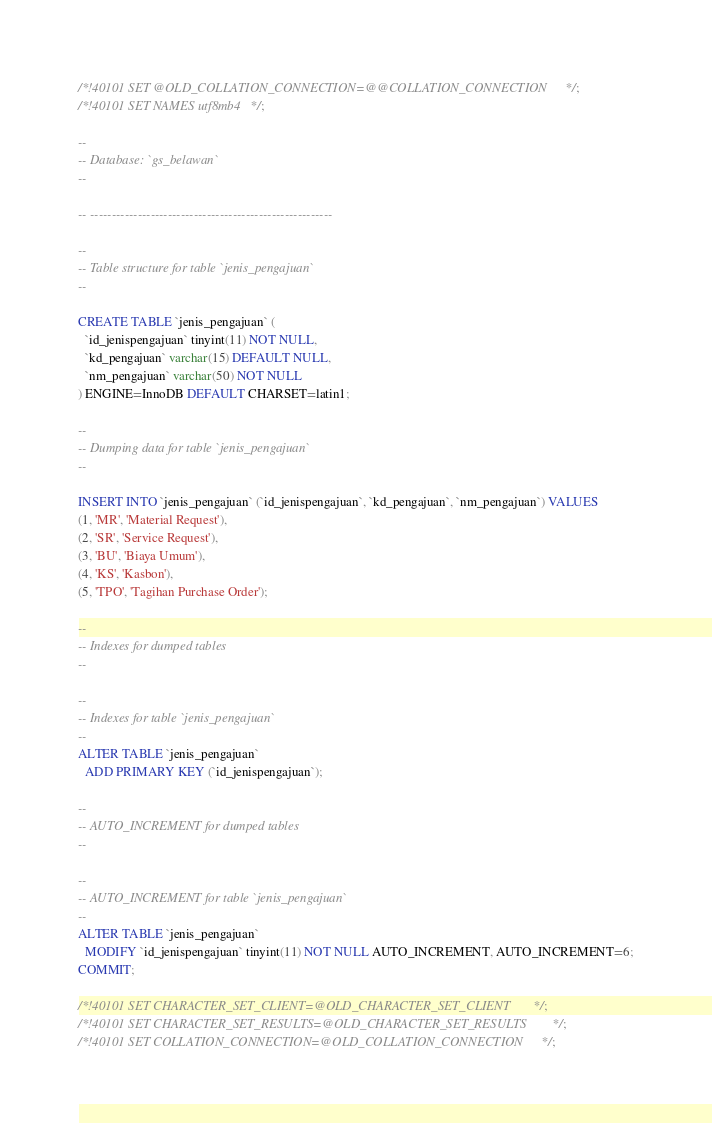Convert code to text. <code><loc_0><loc_0><loc_500><loc_500><_SQL_>/*!40101 SET @OLD_COLLATION_CONNECTION=@@COLLATION_CONNECTION */;
/*!40101 SET NAMES utf8mb4 */;

--
-- Database: `gs_belawan`
--

-- --------------------------------------------------------

--
-- Table structure for table `jenis_pengajuan`
--

CREATE TABLE `jenis_pengajuan` (
  `id_jenispengajuan` tinyint(11) NOT NULL,
  `kd_pengajuan` varchar(15) DEFAULT NULL,
  `nm_pengajuan` varchar(50) NOT NULL
) ENGINE=InnoDB DEFAULT CHARSET=latin1;

--
-- Dumping data for table `jenis_pengajuan`
--

INSERT INTO `jenis_pengajuan` (`id_jenispengajuan`, `kd_pengajuan`, `nm_pengajuan`) VALUES
(1, 'MR', 'Material Request'),
(2, 'SR', 'Service Request'),
(3, 'BU', 'Biaya Umum'),
(4, 'KS', 'Kasbon'),
(5, 'TPO', 'Tagihan Purchase Order');

--
-- Indexes for dumped tables
--

--
-- Indexes for table `jenis_pengajuan`
--
ALTER TABLE `jenis_pengajuan`
  ADD PRIMARY KEY (`id_jenispengajuan`);

--
-- AUTO_INCREMENT for dumped tables
--

--
-- AUTO_INCREMENT for table `jenis_pengajuan`
--
ALTER TABLE `jenis_pengajuan`
  MODIFY `id_jenispengajuan` tinyint(11) NOT NULL AUTO_INCREMENT, AUTO_INCREMENT=6;
COMMIT;

/*!40101 SET CHARACTER_SET_CLIENT=@OLD_CHARACTER_SET_CLIENT */;
/*!40101 SET CHARACTER_SET_RESULTS=@OLD_CHARACTER_SET_RESULTS */;
/*!40101 SET COLLATION_CONNECTION=@OLD_COLLATION_CONNECTION */;
</code> 